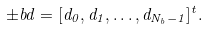<formula> <loc_0><loc_0><loc_500><loc_500>\pm b { d } = [ d _ { 0 } , d _ { 1 } , \dots , d _ { N _ { b } - 1 } ] ^ { t } .</formula> 